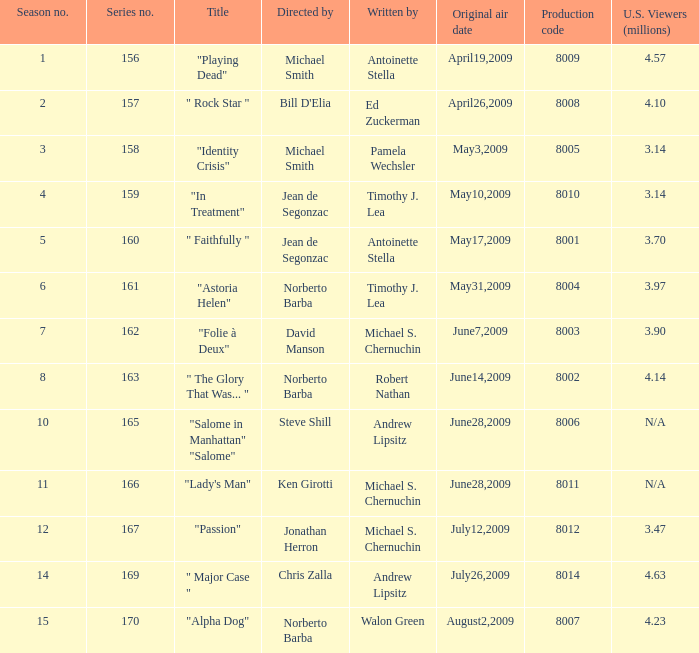What is the highest episode number in a series when there are 3.14 million north american viewers? 159.0. 